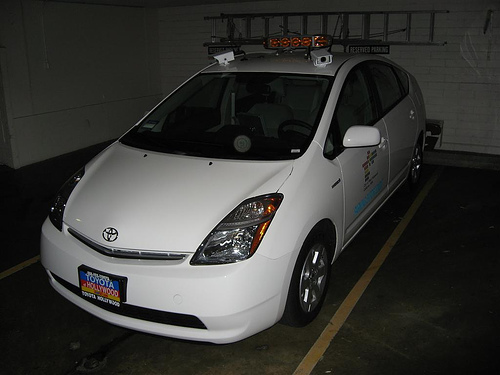<image>
Is the ladder on the car? No. The ladder is not positioned on the car. They may be near each other, but the ladder is not supported by or resting on top of the car. 